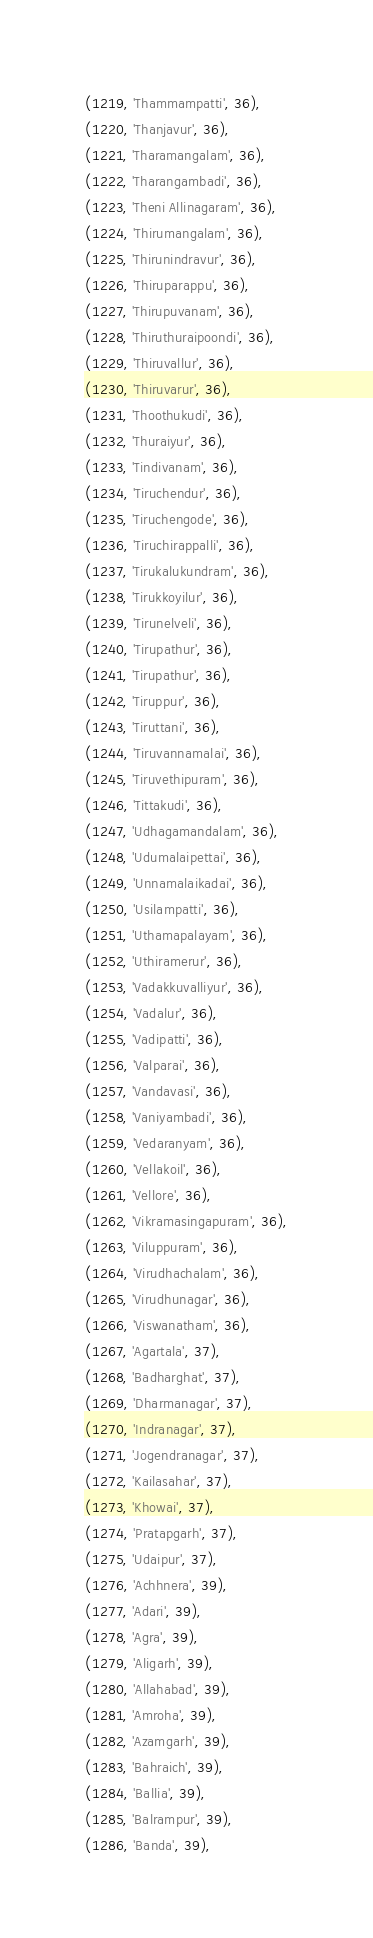<code> <loc_0><loc_0><loc_500><loc_500><_SQL_>(1219, 'Thammampatti', 36),
(1220, 'Thanjavur', 36),
(1221, 'Tharamangalam', 36),
(1222, 'Tharangambadi', 36),
(1223, 'Theni Allinagaram', 36),
(1224, 'Thirumangalam', 36),
(1225, 'Thirunindravur', 36),
(1226, 'Thiruparappu', 36),
(1227, 'Thirupuvanam', 36),
(1228, 'Thiruthuraipoondi', 36),
(1229, 'Thiruvallur', 36),
(1230, 'Thiruvarur', 36),
(1231, 'Thoothukudi', 36),
(1232, 'Thuraiyur', 36),
(1233, 'Tindivanam', 36),
(1234, 'Tiruchendur', 36),
(1235, 'Tiruchengode', 36),
(1236, 'Tiruchirappalli', 36),
(1237, 'Tirukalukundram', 36),
(1238, 'Tirukkoyilur', 36),
(1239, 'Tirunelveli', 36),
(1240, 'Tirupathur', 36),
(1241, 'Tirupathur', 36),
(1242, 'Tiruppur', 36),
(1243, 'Tiruttani', 36),
(1244, 'Tiruvannamalai', 36),
(1245, 'Tiruvethipuram', 36),
(1246, 'Tittakudi', 36),
(1247, 'Udhagamandalam', 36),
(1248, 'Udumalaipettai', 36),
(1249, 'Unnamalaikadai', 36),
(1250, 'Usilampatti', 36),
(1251, 'Uthamapalayam', 36),
(1252, 'Uthiramerur', 36),
(1253, 'Vadakkuvalliyur', 36),
(1254, 'Vadalur', 36),
(1255, 'Vadipatti', 36),
(1256, 'Valparai', 36),
(1257, 'Vandavasi', 36),
(1258, 'Vaniyambadi', 36),
(1259, 'Vedaranyam', 36),
(1260, 'Vellakoil', 36),
(1261, 'Vellore', 36),
(1262, 'Vikramasingapuram', 36),
(1263, 'Viluppuram', 36),
(1264, 'Virudhachalam', 36),
(1265, 'Virudhunagar', 36),
(1266, 'Viswanatham', 36),
(1267, 'Agartala', 37),
(1268, 'Badharghat', 37),
(1269, 'Dharmanagar', 37),
(1270, 'Indranagar', 37),
(1271, 'Jogendranagar', 37),
(1272, 'Kailasahar', 37),
(1273, 'Khowai', 37),
(1274, 'Pratapgarh', 37),
(1275, 'Udaipur', 37),
(1276, 'Achhnera', 39),
(1277, 'Adari', 39),
(1278, 'Agra', 39),
(1279, 'Aligarh', 39),
(1280, 'Allahabad', 39),
(1281, 'Amroha', 39),
(1282, 'Azamgarh', 39),
(1283, 'Bahraich', 39),
(1284, 'Ballia', 39),
(1285, 'Balrampur', 39),
(1286, 'Banda', 39),</code> 